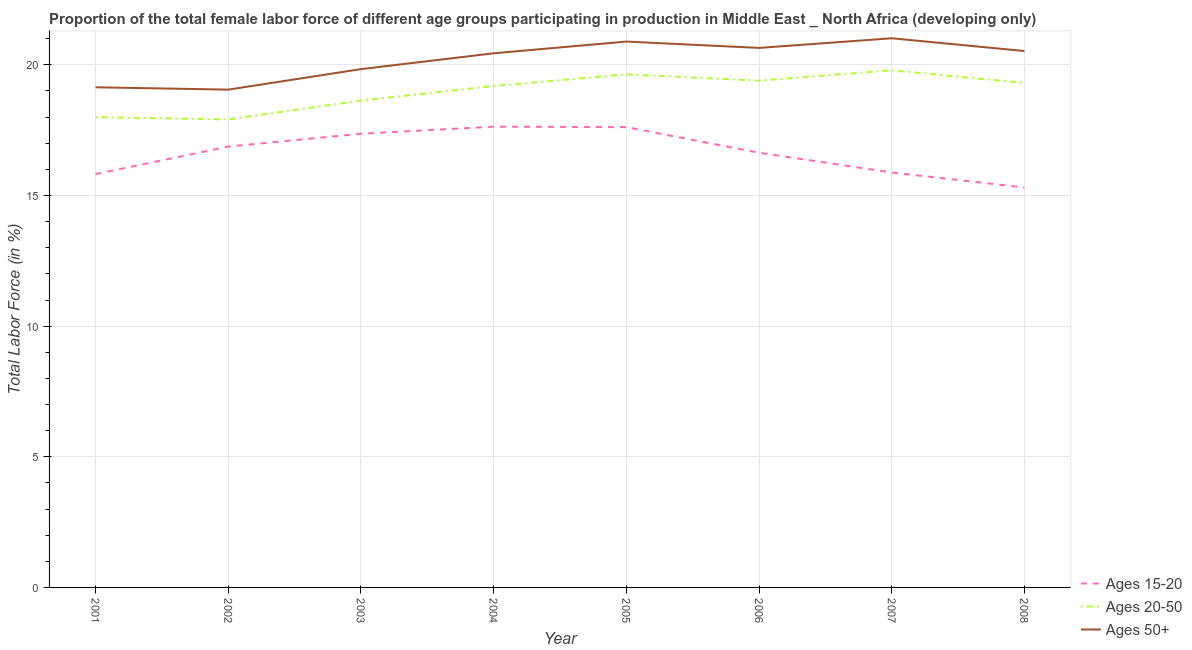What is the percentage of female labor force above age 50 in 2003?
Your response must be concise. 19.84. Across all years, what is the maximum percentage of female labor force within the age group 20-50?
Your response must be concise. 19.79. Across all years, what is the minimum percentage of female labor force within the age group 20-50?
Make the answer very short. 17.91. In which year was the percentage of female labor force within the age group 20-50 minimum?
Provide a short and direct response. 2002. What is the total percentage of female labor force above age 50 in the graph?
Ensure brevity in your answer.  161.56. What is the difference between the percentage of female labor force within the age group 20-50 in 2001 and that in 2005?
Your response must be concise. -1.64. What is the difference between the percentage of female labor force within the age group 20-50 in 2007 and the percentage of female labor force within the age group 15-20 in 2006?
Keep it short and to the point. 3.16. What is the average percentage of female labor force within the age group 20-50 per year?
Provide a succinct answer. 18.98. In the year 2008, what is the difference between the percentage of female labor force within the age group 15-20 and percentage of female labor force within the age group 20-50?
Ensure brevity in your answer.  -4. What is the ratio of the percentage of female labor force above age 50 in 2002 to that in 2003?
Provide a succinct answer. 0.96. Is the percentage of female labor force within the age group 15-20 in 2003 less than that in 2005?
Your response must be concise. Yes. Is the difference between the percentage of female labor force within the age group 20-50 in 2002 and 2003 greater than the difference between the percentage of female labor force above age 50 in 2002 and 2003?
Give a very brief answer. Yes. What is the difference between the highest and the second highest percentage of female labor force above age 50?
Provide a short and direct response. 0.13. What is the difference between the highest and the lowest percentage of female labor force above age 50?
Provide a short and direct response. 1.97. Does the percentage of female labor force above age 50 monotonically increase over the years?
Your response must be concise. No. Is the percentage of female labor force within the age group 20-50 strictly less than the percentage of female labor force within the age group 15-20 over the years?
Provide a succinct answer. No. How many years are there in the graph?
Your answer should be compact. 8. Are the values on the major ticks of Y-axis written in scientific E-notation?
Offer a very short reply. No. Does the graph contain any zero values?
Keep it short and to the point. No. Does the graph contain grids?
Offer a very short reply. Yes. Where does the legend appear in the graph?
Give a very brief answer. Bottom right. What is the title of the graph?
Your answer should be compact. Proportion of the total female labor force of different age groups participating in production in Middle East _ North Africa (developing only). What is the label or title of the X-axis?
Provide a succinct answer. Year. What is the label or title of the Y-axis?
Keep it short and to the point. Total Labor Force (in %). What is the Total Labor Force (in %) in Ages 15-20 in 2001?
Make the answer very short. 15.82. What is the Total Labor Force (in %) of Ages 20-50 in 2001?
Your answer should be compact. 18. What is the Total Labor Force (in %) of Ages 50+ in 2001?
Your answer should be compact. 19.14. What is the Total Labor Force (in %) in Ages 15-20 in 2002?
Make the answer very short. 16.87. What is the Total Labor Force (in %) in Ages 20-50 in 2002?
Give a very brief answer. 17.91. What is the Total Labor Force (in %) of Ages 50+ in 2002?
Provide a succinct answer. 19.05. What is the Total Labor Force (in %) of Ages 15-20 in 2003?
Your answer should be very brief. 17.37. What is the Total Labor Force (in %) in Ages 20-50 in 2003?
Provide a succinct answer. 18.63. What is the Total Labor Force (in %) of Ages 50+ in 2003?
Give a very brief answer. 19.84. What is the Total Labor Force (in %) of Ages 15-20 in 2004?
Your response must be concise. 17.63. What is the Total Labor Force (in %) in Ages 20-50 in 2004?
Provide a succinct answer. 19.19. What is the Total Labor Force (in %) in Ages 50+ in 2004?
Provide a succinct answer. 20.44. What is the Total Labor Force (in %) in Ages 15-20 in 2005?
Ensure brevity in your answer.  17.62. What is the Total Labor Force (in %) in Ages 20-50 in 2005?
Keep it short and to the point. 19.64. What is the Total Labor Force (in %) of Ages 50+ in 2005?
Offer a very short reply. 20.89. What is the Total Labor Force (in %) in Ages 15-20 in 2006?
Offer a very short reply. 16.64. What is the Total Labor Force (in %) of Ages 20-50 in 2006?
Offer a very short reply. 19.4. What is the Total Labor Force (in %) in Ages 50+ in 2006?
Give a very brief answer. 20.65. What is the Total Labor Force (in %) in Ages 15-20 in 2007?
Provide a succinct answer. 15.88. What is the Total Labor Force (in %) of Ages 20-50 in 2007?
Make the answer very short. 19.79. What is the Total Labor Force (in %) in Ages 50+ in 2007?
Your response must be concise. 21.02. What is the Total Labor Force (in %) in Ages 15-20 in 2008?
Your answer should be compact. 15.31. What is the Total Labor Force (in %) of Ages 20-50 in 2008?
Provide a succinct answer. 19.31. What is the Total Labor Force (in %) in Ages 50+ in 2008?
Keep it short and to the point. 20.53. Across all years, what is the maximum Total Labor Force (in %) in Ages 15-20?
Provide a short and direct response. 17.63. Across all years, what is the maximum Total Labor Force (in %) in Ages 20-50?
Your answer should be very brief. 19.79. Across all years, what is the maximum Total Labor Force (in %) of Ages 50+?
Make the answer very short. 21.02. Across all years, what is the minimum Total Labor Force (in %) of Ages 15-20?
Provide a short and direct response. 15.31. Across all years, what is the minimum Total Labor Force (in %) of Ages 20-50?
Your response must be concise. 17.91. Across all years, what is the minimum Total Labor Force (in %) of Ages 50+?
Give a very brief answer. 19.05. What is the total Total Labor Force (in %) of Ages 15-20 in the graph?
Keep it short and to the point. 133.13. What is the total Total Labor Force (in %) of Ages 20-50 in the graph?
Provide a short and direct response. 151.87. What is the total Total Labor Force (in %) in Ages 50+ in the graph?
Your response must be concise. 161.56. What is the difference between the Total Labor Force (in %) of Ages 15-20 in 2001 and that in 2002?
Your answer should be compact. -1.05. What is the difference between the Total Labor Force (in %) in Ages 20-50 in 2001 and that in 2002?
Keep it short and to the point. 0.09. What is the difference between the Total Labor Force (in %) of Ages 50+ in 2001 and that in 2002?
Give a very brief answer. 0.09. What is the difference between the Total Labor Force (in %) in Ages 15-20 in 2001 and that in 2003?
Offer a very short reply. -1.55. What is the difference between the Total Labor Force (in %) in Ages 20-50 in 2001 and that in 2003?
Ensure brevity in your answer.  -0.63. What is the difference between the Total Labor Force (in %) in Ages 50+ in 2001 and that in 2003?
Make the answer very short. -0.69. What is the difference between the Total Labor Force (in %) of Ages 15-20 in 2001 and that in 2004?
Ensure brevity in your answer.  -1.82. What is the difference between the Total Labor Force (in %) in Ages 20-50 in 2001 and that in 2004?
Offer a very short reply. -1.19. What is the difference between the Total Labor Force (in %) of Ages 50+ in 2001 and that in 2004?
Your response must be concise. -1.3. What is the difference between the Total Labor Force (in %) of Ages 15-20 in 2001 and that in 2005?
Offer a terse response. -1.8. What is the difference between the Total Labor Force (in %) of Ages 20-50 in 2001 and that in 2005?
Offer a very short reply. -1.64. What is the difference between the Total Labor Force (in %) of Ages 50+ in 2001 and that in 2005?
Your response must be concise. -1.75. What is the difference between the Total Labor Force (in %) in Ages 15-20 in 2001 and that in 2006?
Ensure brevity in your answer.  -0.82. What is the difference between the Total Labor Force (in %) of Ages 20-50 in 2001 and that in 2006?
Give a very brief answer. -1.4. What is the difference between the Total Labor Force (in %) of Ages 50+ in 2001 and that in 2006?
Keep it short and to the point. -1.51. What is the difference between the Total Labor Force (in %) of Ages 15-20 in 2001 and that in 2007?
Give a very brief answer. -0.06. What is the difference between the Total Labor Force (in %) in Ages 20-50 in 2001 and that in 2007?
Keep it short and to the point. -1.79. What is the difference between the Total Labor Force (in %) in Ages 50+ in 2001 and that in 2007?
Ensure brevity in your answer.  -1.88. What is the difference between the Total Labor Force (in %) in Ages 15-20 in 2001 and that in 2008?
Offer a very short reply. 0.51. What is the difference between the Total Labor Force (in %) in Ages 20-50 in 2001 and that in 2008?
Your response must be concise. -1.31. What is the difference between the Total Labor Force (in %) of Ages 50+ in 2001 and that in 2008?
Make the answer very short. -1.39. What is the difference between the Total Labor Force (in %) of Ages 15-20 in 2002 and that in 2003?
Your answer should be compact. -0.49. What is the difference between the Total Labor Force (in %) of Ages 20-50 in 2002 and that in 2003?
Make the answer very short. -0.72. What is the difference between the Total Labor Force (in %) in Ages 50+ in 2002 and that in 2003?
Ensure brevity in your answer.  -0.78. What is the difference between the Total Labor Force (in %) of Ages 15-20 in 2002 and that in 2004?
Provide a short and direct response. -0.76. What is the difference between the Total Labor Force (in %) in Ages 20-50 in 2002 and that in 2004?
Your answer should be very brief. -1.28. What is the difference between the Total Labor Force (in %) in Ages 50+ in 2002 and that in 2004?
Your answer should be compact. -1.39. What is the difference between the Total Labor Force (in %) of Ages 15-20 in 2002 and that in 2005?
Offer a very short reply. -0.74. What is the difference between the Total Labor Force (in %) in Ages 20-50 in 2002 and that in 2005?
Provide a short and direct response. -1.72. What is the difference between the Total Labor Force (in %) in Ages 50+ in 2002 and that in 2005?
Give a very brief answer. -1.84. What is the difference between the Total Labor Force (in %) of Ages 15-20 in 2002 and that in 2006?
Provide a succinct answer. 0.24. What is the difference between the Total Labor Force (in %) of Ages 20-50 in 2002 and that in 2006?
Ensure brevity in your answer.  -1.48. What is the difference between the Total Labor Force (in %) of Ages 50+ in 2002 and that in 2006?
Give a very brief answer. -1.6. What is the difference between the Total Labor Force (in %) in Ages 20-50 in 2002 and that in 2007?
Ensure brevity in your answer.  -1.88. What is the difference between the Total Labor Force (in %) of Ages 50+ in 2002 and that in 2007?
Your answer should be compact. -1.97. What is the difference between the Total Labor Force (in %) of Ages 15-20 in 2002 and that in 2008?
Ensure brevity in your answer.  1.56. What is the difference between the Total Labor Force (in %) of Ages 20-50 in 2002 and that in 2008?
Make the answer very short. -1.4. What is the difference between the Total Labor Force (in %) of Ages 50+ in 2002 and that in 2008?
Offer a very short reply. -1.48. What is the difference between the Total Labor Force (in %) in Ages 15-20 in 2003 and that in 2004?
Your response must be concise. -0.27. What is the difference between the Total Labor Force (in %) of Ages 20-50 in 2003 and that in 2004?
Your answer should be compact. -0.56. What is the difference between the Total Labor Force (in %) in Ages 50+ in 2003 and that in 2004?
Provide a succinct answer. -0.61. What is the difference between the Total Labor Force (in %) in Ages 15-20 in 2003 and that in 2005?
Offer a terse response. -0.25. What is the difference between the Total Labor Force (in %) of Ages 20-50 in 2003 and that in 2005?
Offer a very short reply. -1. What is the difference between the Total Labor Force (in %) of Ages 50+ in 2003 and that in 2005?
Offer a terse response. -1.05. What is the difference between the Total Labor Force (in %) in Ages 15-20 in 2003 and that in 2006?
Provide a short and direct response. 0.73. What is the difference between the Total Labor Force (in %) of Ages 20-50 in 2003 and that in 2006?
Give a very brief answer. -0.76. What is the difference between the Total Labor Force (in %) of Ages 50+ in 2003 and that in 2006?
Ensure brevity in your answer.  -0.81. What is the difference between the Total Labor Force (in %) in Ages 15-20 in 2003 and that in 2007?
Ensure brevity in your answer.  1.48. What is the difference between the Total Labor Force (in %) of Ages 20-50 in 2003 and that in 2007?
Give a very brief answer. -1.16. What is the difference between the Total Labor Force (in %) of Ages 50+ in 2003 and that in 2007?
Provide a succinct answer. -1.18. What is the difference between the Total Labor Force (in %) in Ages 15-20 in 2003 and that in 2008?
Your answer should be very brief. 2.06. What is the difference between the Total Labor Force (in %) in Ages 20-50 in 2003 and that in 2008?
Your answer should be very brief. -0.67. What is the difference between the Total Labor Force (in %) of Ages 50+ in 2003 and that in 2008?
Offer a terse response. -0.69. What is the difference between the Total Labor Force (in %) in Ages 15-20 in 2004 and that in 2005?
Your answer should be very brief. 0.02. What is the difference between the Total Labor Force (in %) of Ages 20-50 in 2004 and that in 2005?
Give a very brief answer. -0.44. What is the difference between the Total Labor Force (in %) of Ages 50+ in 2004 and that in 2005?
Your response must be concise. -0.45. What is the difference between the Total Labor Force (in %) in Ages 15-20 in 2004 and that in 2006?
Your answer should be compact. 1. What is the difference between the Total Labor Force (in %) of Ages 20-50 in 2004 and that in 2006?
Your answer should be very brief. -0.21. What is the difference between the Total Labor Force (in %) in Ages 50+ in 2004 and that in 2006?
Your answer should be compact. -0.21. What is the difference between the Total Labor Force (in %) of Ages 15-20 in 2004 and that in 2007?
Your answer should be compact. 1.75. What is the difference between the Total Labor Force (in %) in Ages 20-50 in 2004 and that in 2007?
Offer a terse response. -0.6. What is the difference between the Total Labor Force (in %) of Ages 50+ in 2004 and that in 2007?
Your answer should be compact. -0.57. What is the difference between the Total Labor Force (in %) in Ages 15-20 in 2004 and that in 2008?
Provide a short and direct response. 2.33. What is the difference between the Total Labor Force (in %) of Ages 20-50 in 2004 and that in 2008?
Ensure brevity in your answer.  -0.12. What is the difference between the Total Labor Force (in %) of Ages 50+ in 2004 and that in 2008?
Your answer should be compact. -0.09. What is the difference between the Total Labor Force (in %) in Ages 20-50 in 2005 and that in 2006?
Your answer should be compact. 0.24. What is the difference between the Total Labor Force (in %) in Ages 50+ in 2005 and that in 2006?
Offer a very short reply. 0.24. What is the difference between the Total Labor Force (in %) in Ages 15-20 in 2005 and that in 2007?
Your response must be concise. 1.74. What is the difference between the Total Labor Force (in %) in Ages 20-50 in 2005 and that in 2007?
Offer a terse response. -0.16. What is the difference between the Total Labor Force (in %) of Ages 50+ in 2005 and that in 2007?
Your answer should be compact. -0.13. What is the difference between the Total Labor Force (in %) in Ages 15-20 in 2005 and that in 2008?
Your response must be concise. 2.31. What is the difference between the Total Labor Force (in %) of Ages 20-50 in 2005 and that in 2008?
Your answer should be very brief. 0.33. What is the difference between the Total Labor Force (in %) of Ages 50+ in 2005 and that in 2008?
Offer a very short reply. 0.36. What is the difference between the Total Labor Force (in %) in Ages 15-20 in 2006 and that in 2007?
Ensure brevity in your answer.  0.76. What is the difference between the Total Labor Force (in %) of Ages 20-50 in 2006 and that in 2007?
Your answer should be very brief. -0.4. What is the difference between the Total Labor Force (in %) in Ages 50+ in 2006 and that in 2007?
Give a very brief answer. -0.37. What is the difference between the Total Labor Force (in %) of Ages 15-20 in 2006 and that in 2008?
Offer a very short reply. 1.33. What is the difference between the Total Labor Force (in %) of Ages 20-50 in 2006 and that in 2008?
Offer a very short reply. 0.09. What is the difference between the Total Labor Force (in %) in Ages 50+ in 2006 and that in 2008?
Provide a short and direct response. 0.12. What is the difference between the Total Labor Force (in %) of Ages 15-20 in 2007 and that in 2008?
Your response must be concise. 0.57. What is the difference between the Total Labor Force (in %) of Ages 20-50 in 2007 and that in 2008?
Give a very brief answer. 0.49. What is the difference between the Total Labor Force (in %) of Ages 50+ in 2007 and that in 2008?
Make the answer very short. 0.49. What is the difference between the Total Labor Force (in %) of Ages 15-20 in 2001 and the Total Labor Force (in %) of Ages 20-50 in 2002?
Provide a short and direct response. -2.09. What is the difference between the Total Labor Force (in %) in Ages 15-20 in 2001 and the Total Labor Force (in %) in Ages 50+ in 2002?
Offer a very short reply. -3.23. What is the difference between the Total Labor Force (in %) in Ages 20-50 in 2001 and the Total Labor Force (in %) in Ages 50+ in 2002?
Offer a terse response. -1.05. What is the difference between the Total Labor Force (in %) in Ages 15-20 in 2001 and the Total Labor Force (in %) in Ages 20-50 in 2003?
Provide a succinct answer. -2.81. What is the difference between the Total Labor Force (in %) in Ages 15-20 in 2001 and the Total Labor Force (in %) in Ages 50+ in 2003?
Make the answer very short. -4.02. What is the difference between the Total Labor Force (in %) of Ages 20-50 in 2001 and the Total Labor Force (in %) of Ages 50+ in 2003?
Provide a succinct answer. -1.84. What is the difference between the Total Labor Force (in %) in Ages 15-20 in 2001 and the Total Labor Force (in %) in Ages 20-50 in 2004?
Offer a terse response. -3.37. What is the difference between the Total Labor Force (in %) in Ages 15-20 in 2001 and the Total Labor Force (in %) in Ages 50+ in 2004?
Provide a short and direct response. -4.62. What is the difference between the Total Labor Force (in %) in Ages 20-50 in 2001 and the Total Labor Force (in %) in Ages 50+ in 2004?
Offer a terse response. -2.44. What is the difference between the Total Labor Force (in %) of Ages 15-20 in 2001 and the Total Labor Force (in %) of Ages 20-50 in 2005?
Your response must be concise. -3.82. What is the difference between the Total Labor Force (in %) of Ages 15-20 in 2001 and the Total Labor Force (in %) of Ages 50+ in 2005?
Give a very brief answer. -5.07. What is the difference between the Total Labor Force (in %) of Ages 20-50 in 2001 and the Total Labor Force (in %) of Ages 50+ in 2005?
Give a very brief answer. -2.89. What is the difference between the Total Labor Force (in %) in Ages 15-20 in 2001 and the Total Labor Force (in %) in Ages 20-50 in 2006?
Provide a succinct answer. -3.58. What is the difference between the Total Labor Force (in %) in Ages 15-20 in 2001 and the Total Labor Force (in %) in Ages 50+ in 2006?
Your answer should be compact. -4.83. What is the difference between the Total Labor Force (in %) in Ages 20-50 in 2001 and the Total Labor Force (in %) in Ages 50+ in 2006?
Provide a succinct answer. -2.65. What is the difference between the Total Labor Force (in %) of Ages 15-20 in 2001 and the Total Labor Force (in %) of Ages 20-50 in 2007?
Provide a succinct answer. -3.97. What is the difference between the Total Labor Force (in %) of Ages 15-20 in 2001 and the Total Labor Force (in %) of Ages 50+ in 2007?
Offer a terse response. -5.2. What is the difference between the Total Labor Force (in %) in Ages 20-50 in 2001 and the Total Labor Force (in %) in Ages 50+ in 2007?
Offer a terse response. -3.02. What is the difference between the Total Labor Force (in %) of Ages 15-20 in 2001 and the Total Labor Force (in %) of Ages 20-50 in 2008?
Ensure brevity in your answer.  -3.49. What is the difference between the Total Labor Force (in %) in Ages 15-20 in 2001 and the Total Labor Force (in %) in Ages 50+ in 2008?
Provide a short and direct response. -4.71. What is the difference between the Total Labor Force (in %) of Ages 20-50 in 2001 and the Total Labor Force (in %) of Ages 50+ in 2008?
Your response must be concise. -2.53. What is the difference between the Total Labor Force (in %) in Ages 15-20 in 2002 and the Total Labor Force (in %) in Ages 20-50 in 2003?
Provide a short and direct response. -1.76. What is the difference between the Total Labor Force (in %) of Ages 15-20 in 2002 and the Total Labor Force (in %) of Ages 50+ in 2003?
Provide a succinct answer. -2.96. What is the difference between the Total Labor Force (in %) of Ages 20-50 in 2002 and the Total Labor Force (in %) of Ages 50+ in 2003?
Make the answer very short. -1.93. What is the difference between the Total Labor Force (in %) in Ages 15-20 in 2002 and the Total Labor Force (in %) in Ages 20-50 in 2004?
Make the answer very short. -2.32. What is the difference between the Total Labor Force (in %) in Ages 15-20 in 2002 and the Total Labor Force (in %) in Ages 50+ in 2004?
Provide a short and direct response. -3.57. What is the difference between the Total Labor Force (in %) in Ages 20-50 in 2002 and the Total Labor Force (in %) in Ages 50+ in 2004?
Offer a very short reply. -2.53. What is the difference between the Total Labor Force (in %) in Ages 15-20 in 2002 and the Total Labor Force (in %) in Ages 20-50 in 2005?
Your answer should be compact. -2.76. What is the difference between the Total Labor Force (in %) of Ages 15-20 in 2002 and the Total Labor Force (in %) of Ages 50+ in 2005?
Offer a terse response. -4.02. What is the difference between the Total Labor Force (in %) of Ages 20-50 in 2002 and the Total Labor Force (in %) of Ages 50+ in 2005?
Your response must be concise. -2.98. What is the difference between the Total Labor Force (in %) of Ages 15-20 in 2002 and the Total Labor Force (in %) of Ages 20-50 in 2006?
Your answer should be compact. -2.52. What is the difference between the Total Labor Force (in %) in Ages 15-20 in 2002 and the Total Labor Force (in %) in Ages 50+ in 2006?
Keep it short and to the point. -3.78. What is the difference between the Total Labor Force (in %) in Ages 20-50 in 2002 and the Total Labor Force (in %) in Ages 50+ in 2006?
Make the answer very short. -2.74. What is the difference between the Total Labor Force (in %) in Ages 15-20 in 2002 and the Total Labor Force (in %) in Ages 20-50 in 2007?
Your answer should be very brief. -2.92. What is the difference between the Total Labor Force (in %) of Ages 15-20 in 2002 and the Total Labor Force (in %) of Ages 50+ in 2007?
Provide a short and direct response. -4.15. What is the difference between the Total Labor Force (in %) of Ages 20-50 in 2002 and the Total Labor Force (in %) of Ages 50+ in 2007?
Provide a succinct answer. -3.11. What is the difference between the Total Labor Force (in %) in Ages 15-20 in 2002 and the Total Labor Force (in %) in Ages 20-50 in 2008?
Make the answer very short. -2.44. What is the difference between the Total Labor Force (in %) of Ages 15-20 in 2002 and the Total Labor Force (in %) of Ages 50+ in 2008?
Your answer should be very brief. -3.66. What is the difference between the Total Labor Force (in %) of Ages 20-50 in 2002 and the Total Labor Force (in %) of Ages 50+ in 2008?
Ensure brevity in your answer.  -2.62. What is the difference between the Total Labor Force (in %) of Ages 15-20 in 2003 and the Total Labor Force (in %) of Ages 20-50 in 2004?
Your answer should be compact. -1.83. What is the difference between the Total Labor Force (in %) in Ages 15-20 in 2003 and the Total Labor Force (in %) in Ages 50+ in 2004?
Keep it short and to the point. -3.08. What is the difference between the Total Labor Force (in %) in Ages 20-50 in 2003 and the Total Labor Force (in %) in Ages 50+ in 2004?
Your answer should be very brief. -1.81. What is the difference between the Total Labor Force (in %) in Ages 15-20 in 2003 and the Total Labor Force (in %) in Ages 20-50 in 2005?
Make the answer very short. -2.27. What is the difference between the Total Labor Force (in %) in Ages 15-20 in 2003 and the Total Labor Force (in %) in Ages 50+ in 2005?
Provide a short and direct response. -3.53. What is the difference between the Total Labor Force (in %) in Ages 20-50 in 2003 and the Total Labor Force (in %) in Ages 50+ in 2005?
Provide a short and direct response. -2.26. What is the difference between the Total Labor Force (in %) of Ages 15-20 in 2003 and the Total Labor Force (in %) of Ages 20-50 in 2006?
Your answer should be very brief. -2.03. What is the difference between the Total Labor Force (in %) of Ages 15-20 in 2003 and the Total Labor Force (in %) of Ages 50+ in 2006?
Offer a very short reply. -3.28. What is the difference between the Total Labor Force (in %) in Ages 20-50 in 2003 and the Total Labor Force (in %) in Ages 50+ in 2006?
Keep it short and to the point. -2.02. What is the difference between the Total Labor Force (in %) in Ages 15-20 in 2003 and the Total Labor Force (in %) in Ages 20-50 in 2007?
Your answer should be very brief. -2.43. What is the difference between the Total Labor Force (in %) of Ages 15-20 in 2003 and the Total Labor Force (in %) of Ages 50+ in 2007?
Provide a succinct answer. -3.65. What is the difference between the Total Labor Force (in %) in Ages 20-50 in 2003 and the Total Labor Force (in %) in Ages 50+ in 2007?
Make the answer very short. -2.38. What is the difference between the Total Labor Force (in %) in Ages 15-20 in 2003 and the Total Labor Force (in %) in Ages 20-50 in 2008?
Offer a very short reply. -1.94. What is the difference between the Total Labor Force (in %) in Ages 15-20 in 2003 and the Total Labor Force (in %) in Ages 50+ in 2008?
Provide a succinct answer. -3.16. What is the difference between the Total Labor Force (in %) in Ages 20-50 in 2003 and the Total Labor Force (in %) in Ages 50+ in 2008?
Give a very brief answer. -1.9. What is the difference between the Total Labor Force (in %) in Ages 15-20 in 2004 and the Total Labor Force (in %) in Ages 20-50 in 2005?
Make the answer very short. -2. What is the difference between the Total Labor Force (in %) of Ages 15-20 in 2004 and the Total Labor Force (in %) of Ages 50+ in 2005?
Offer a terse response. -3.26. What is the difference between the Total Labor Force (in %) in Ages 20-50 in 2004 and the Total Labor Force (in %) in Ages 50+ in 2005?
Ensure brevity in your answer.  -1.7. What is the difference between the Total Labor Force (in %) of Ages 15-20 in 2004 and the Total Labor Force (in %) of Ages 20-50 in 2006?
Ensure brevity in your answer.  -1.76. What is the difference between the Total Labor Force (in %) in Ages 15-20 in 2004 and the Total Labor Force (in %) in Ages 50+ in 2006?
Give a very brief answer. -3.01. What is the difference between the Total Labor Force (in %) of Ages 20-50 in 2004 and the Total Labor Force (in %) of Ages 50+ in 2006?
Keep it short and to the point. -1.46. What is the difference between the Total Labor Force (in %) of Ages 15-20 in 2004 and the Total Labor Force (in %) of Ages 20-50 in 2007?
Offer a very short reply. -2.16. What is the difference between the Total Labor Force (in %) in Ages 15-20 in 2004 and the Total Labor Force (in %) in Ages 50+ in 2007?
Your response must be concise. -3.38. What is the difference between the Total Labor Force (in %) of Ages 20-50 in 2004 and the Total Labor Force (in %) of Ages 50+ in 2007?
Your answer should be compact. -1.83. What is the difference between the Total Labor Force (in %) of Ages 15-20 in 2004 and the Total Labor Force (in %) of Ages 20-50 in 2008?
Ensure brevity in your answer.  -1.67. What is the difference between the Total Labor Force (in %) in Ages 15-20 in 2004 and the Total Labor Force (in %) in Ages 50+ in 2008?
Your answer should be very brief. -2.89. What is the difference between the Total Labor Force (in %) of Ages 20-50 in 2004 and the Total Labor Force (in %) of Ages 50+ in 2008?
Offer a very short reply. -1.34. What is the difference between the Total Labor Force (in %) of Ages 15-20 in 2005 and the Total Labor Force (in %) of Ages 20-50 in 2006?
Give a very brief answer. -1.78. What is the difference between the Total Labor Force (in %) in Ages 15-20 in 2005 and the Total Labor Force (in %) in Ages 50+ in 2006?
Provide a short and direct response. -3.03. What is the difference between the Total Labor Force (in %) of Ages 20-50 in 2005 and the Total Labor Force (in %) of Ages 50+ in 2006?
Offer a very short reply. -1.01. What is the difference between the Total Labor Force (in %) in Ages 15-20 in 2005 and the Total Labor Force (in %) in Ages 20-50 in 2007?
Your answer should be very brief. -2.18. What is the difference between the Total Labor Force (in %) of Ages 15-20 in 2005 and the Total Labor Force (in %) of Ages 50+ in 2007?
Keep it short and to the point. -3.4. What is the difference between the Total Labor Force (in %) of Ages 20-50 in 2005 and the Total Labor Force (in %) of Ages 50+ in 2007?
Your answer should be very brief. -1.38. What is the difference between the Total Labor Force (in %) of Ages 15-20 in 2005 and the Total Labor Force (in %) of Ages 20-50 in 2008?
Keep it short and to the point. -1.69. What is the difference between the Total Labor Force (in %) in Ages 15-20 in 2005 and the Total Labor Force (in %) in Ages 50+ in 2008?
Provide a succinct answer. -2.91. What is the difference between the Total Labor Force (in %) of Ages 20-50 in 2005 and the Total Labor Force (in %) of Ages 50+ in 2008?
Offer a terse response. -0.89. What is the difference between the Total Labor Force (in %) in Ages 15-20 in 2006 and the Total Labor Force (in %) in Ages 20-50 in 2007?
Your answer should be compact. -3.16. What is the difference between the Total Labor Force (in %) in Ages 15-20 in 2006 and the Total Labor Force (in %) in Ages 50+ in 2007?
Give a very brief answer. -4.38. What is the difference between the Total Labor Force (in %) in Ages 20-50 in 2006 and the Total Labor Force (in %) in Ages 50+ in 2007?
Keep it short and to the point. -1.62. What is the difference between the Total Labor Force (in %) in Ages 15-20 in 2006 and the Total Labor Force (in %) in Ages 20-50 in 2008?
Ensure brevity in your answer.  -2.67. What is the difference between the Total Labor Force (in %) in Ages 15-20 in 2006 and the Total Labor Force (in %) in Ages 50+ in 2008?
Ensure brevity in your answer.  -3.89. What is the difference between the Total Labor Force (in %) of Ages 20-50 in 2006 and the Total Labor Force (in %) of Ages 50+ in 2008?
Provide a short and direct response. -1.13. What is the difference between the Total Labor Force (in %) in Ages 15-20 in 2007 and the Total Labor Force (in %) in Ages 20-50 in 2008?
Offer a very short reply. -3.43. What is the difference between the Total Labor Force (in %) in Ages 15-20 in 2007 and the Total Labor Force (in %) in Ages 50+ in 2008?
Give a very brief answer. -4.65. What is the difference between the Total Labor Force (in %) of Ages 20-50 in 2007 and the Total Labor Force (in %) of Ages 50+ in 2008?
Your response must be concise. -0.74. What is the average Total Labor Force (in %) of Ages 15-20 per year?
Your answer should be very brief. 16.64. What is the average Total Labor Force (in %) of Ages 20-50 per year?
Your answer should be compact. 18.98. What is the average Total Labor Force (in %) in Ages 50+ per year?
Provide a short and direct response. 20.2. In the year 2001, what is the difference between the Total Labor Force (in %) in Ages 15-20 and Total Labor Force (in %) in Ages 20-50?
Provide a short and direct response. -2.18. In the year 2001, what is the difference between the Total Labor Force (in %) of Ages 15-20 and Total Labor Force (in %) of Ages 50+?
Your answer should be compact. -3.32. In the year 2001, what is the difference between the Total Labor Force (in %) in Ages 20-50 and Total Labor Force (in %) in Ages 50+?
Keep it short and to the point. -1.14. In the year 2002, what is the difference between the Total Labor Force (in %) in Ages 15-20 and Total Labor Force (in %) in Ages 20-50?
Your response must be concise. -1.04. In the year 2002, what is the difference between the Total Labor Force (in %) of Ages 15-20 and Total Labor Force (in %) of Ages 50+?
Your answer should be very brief. -2.18. In the year 2002, what is the difference between the Total Labor Force (in %) of Ages 20-50 and Total Labor Force (in %) of Ages 50+?
Offer a very short reply. -1.14. In the year 2003, what is the difference between the Total Labor Force (in %) in Ages 15-20 and Total Labor Force (in %) in Ages 20-50?
Your response must be concise. -1.27. In the year 2003, what is the difference between the Total Labor Force (in %) of Ages 15-20 and Total Labor Force (in %) of Ages 50+?
Your response must be concise. -2.47. In the year 2003, what is the difference between the Total Labor Force (in %) in Ages 20-50 and Total Labor Force (in %) in Ages 50+?
Keep it short and to the point. -1.2. In the year 2004, what is the difference between the Total Labor Force (in %) of Ages 15-20 and Total Labor Force (in %) of Ages 20-50?
Offer a very short reply. -1.56. In the year 2004, what is the difference between the Total Labor Force (in %) of Ages 15-20 and Total Labor Force (in %) of Ages 50+?
Keep it short and to the point. -2.81. In the year 2004, what is the difference between the Total Labor Force (in %) in Ages 20-50 and Total Labor Force (in %) in Ages 50+?
Make the answer very short. -1.25. In the year 2005, what is the difference between the Total Labor Force (in %) in Ages 15-20 and Total Labor Force (in %) in Ages 20-50?
Ensure brevity in your answer.  -2.02. In the year 2005, what is the difference between the Total Labor Force (in %) of Ages 15-20 and Total Labor Force (in %) of Ages 50+?
Provide a succinct answer. -3.27. In the year 2005, what is the difference between the Total Labor Force (in %) in Ages 20-50 and Total Labor Force (in %) in Ages 50+?
Keep it short and to the point. -1.26. In the year 2006, what is the difference between the Total Labor Force (in %) in Ages 15-20 and Total Labor Force (in %) in Ages 20-50?
Your response must be concise. -2.76. In the year 2006, what is the difference between the Total Labor Force (in %) of Ages 15-20 and Total Labor Force (in %) of Ages 50+?
Ensure brevity in your answer.  -4.01. In the year 2006, what is the difference between the Total Labor Force (in %) of Ages 20-50 and Total Labor Force (in %) of Ages 50+?
Ensure brevity in your answer.  -1.25. In the year 2007, what is the difference between the Total Labor Force (in %) in Ages 15-20 and Total Labor Force (in %) in Ages 20-50?
Make the answer very short. -3.91. In the year 2007, what is the difference between the Total Labor Force (in %) in Ages 15-20 and Total Labor Force (in %) in Ages 50+?
Keep it short and to the point. -5.14. In the year 2007, what is the difference between the Total Labor Force (in %) in Ages 20-50 and Total Labor Force (in %) in Ages 50+?
Provide a short and direct response. -1.22. In the year 2008, what is the difference between the Total Labor Force (in %) in Ages 15-20 and Total Labor Force (in %) in Ages 20-50?
Give a very brief answer. -4. In the year 2008, what is the difference between the Total Labor Force (in %) of Ages 15-20 and Total Labor Force (in %) of Ages 50+?
Your answer should be very brief. -5.22. In the year 2008, what is the difference between the Total Labor Force (in %) of Ages 20-50 and Total Labor Force (in %) of Ages 50+?
Give a very brief answer. -1.22. What is the ratio of the Total Labor Force (in %) in Ages 15-20 in 2001 to that in 2002?
Keep it short and to the point. 0.94. What is the ratio of the Total Labor Force (in %) of Ages 20-50 in 2001 to that in 2002?
Offer a terse response. 1. What is the ratio of the Total Labor Force (in %) in Ages 15-20 in 2001 to that in 2003?
Offer a terse response. 0.91. What is the ratio of the Total Labor Force (in %) in Ages 20-50 in 2001 to that in 2003?
Ensure brevity in your answer.  0.97. What is the ratio of the Total Labor Force (in %) in Ages 50+ in 2001 to that in 2003?
Offer a terse response. 0.96. What is the ratio of the Total Labor Force (in %) in Ages 15-20 in 2001 to that in 2004?
Your response must be concise. 0.9. What is the ratio of the Total Labor Force (in %) in Ages 20-50 in 2001 to that in 2004?
Keep it short and to the point. 0.94. What is the ratio of the Total Labor Force (in %) in Ages 50+ in 2001 to that in 2004?
Give a very brief answer. 0.94. What is the ratio of the Total Labor Force (in %) in Ages 15-20 in 2001 to that in 2005?
Ensure brevity in your answer.  0.9. What is the ratio of the Total Labor Force (in %) of Ages 20-50 in 2001 to that in 2005?
Give a very brief answer. 0.92. What is the ratio of the Total Labor Force (in %) in Ages 50+ in 2001 to that in 2005?
Your response must be concise. 0.92. What is the ratio of the Total Labor Force (in %) in Ages 15-20 in 2001 to that in 2006?
Make the answer very short. 0.95. What is the ratio of the Total Labor Force (in %) of Ages 20-50 in 2001 to that in 2006?
Keep it short and to the point. 0.93. What is the ratio of the Total Labor Force (in %) of Ages 50+ in 2001 to that in 2006?
Ensure brevity in your answer.  0.93. What is the ratio of the Total Labor Force (in %) of Ages 20-50 in 2001 to that in 2007?
Your response must be concise. 0.91. What is the ratio of the Total Labor Force (in %) of Ages 50+ in 2001 to that in 2007?
Your response must be concise. 0.91. What is the ratio of the Total Labor Force (in %) in Ages 15-20 in 2001 to that in 2008?
Make the answer very short. 1.03. What is the ratio of the Total Labor Force (in %) in Ages 20-50 in 2001 to that in 2008?
Offer a very short reply. 0.93. What is the ratio of the Total Labor Force (in %) in Ages 50+ in 2001 to that in 2008?
Make the answer very short. 0.93. What is the ratio of the Total Labor Force (in %) of Ages 15-20 in 2002 to that in 2003?
Your response must be concise. 0.97. What is the ratio of the Total Labor Force (in %) of Ages 20-50 in 2002 to that in 2003?
Offer a very short reply. 0.96. What is the ratio of the Total Labor Force (in %) of Ages 50+ in 2002 to that in 2003?
Keep it short and to the point. 0.96. What is the ratio of the Total Labor Force (in %) in Ages 15-20 in 2002 to that in 2004?
Offer a very short reply. 0.96. What is the ratio of the Total Labor Force (in %) of Ages 50+ in 2002 to that in 2004?
Offer a terse response. 0.93. What is the ratio of the Total Labor Force (in %) in Ages 15-20 in 2002 to that in 2005?
Provide a succinct answer. 0.96. What is the ratio of the Total Labor Force (in %) of Ages 20-50 in 2002 to that in 2005?
Offer a very short reply. 0.91. What is the ratio of the Total Labor Force (in %) of Ages 50+ in 2002 to that in 2005?
Keep it short and to the point. 0.91. What is the ratio of the Total Labor Force (in %) in Ages 15-20 in 2002 to that in 2006?
Keep it short and to the point. 1.01. What is the ratio of the Total Labor Force (in %) in Ages 20-50 in 2002 to that in 2006?
Keep it short and to the point. 0.92. What is the ratio of the Total Labor Force (in %) of Ages 50+ in 2002 to that in 2006?
Your response must be concise. 0.92. What is the ratio of the Total Labor Force (in %) of Ages 15-20 in 2002 to that in 2007?
Provide a succinct answer. 1.06. What is the ratio of the Total Labor Force (in %) in Ages 20-50 in 2002 to that in 2007?
Your answer should be compact. 0.9. What is the ratio of the Total Labor Force (in %) in Ages 50+ in 2002 to that in 2007?
Provide a short and direct response. 0.91. What is the ratio of the Total Labor Force (in %) of Ages 15-20 in 2002 to that in 2008?
Make the answer very short. 1.1. What is the ratio of the Total Labor Force (in %) of Ages 20-50 in 2002 to that in 2008?
Provide a succinct answer. 0.93. What is the ratio of the Total Labor Force (in %) in Ages 50+ in 2002 to that in 2008?
Make the answer very short. 0.93. What is the ratio of the Total Labor Force (in %) of Ages 15-20 in 2003 to that in 2004?
Your answer should be very brief. 0.98. What is the ratio of the Total Labor Force (in %) of Ages 50+ in 2003 to that in 2004?
Your response must be concise. 0.97. What is the ratio of the Total Labor Force (in %) in Ages 15-20 in 2003 to that in 2005?
Make the answer very short. 0.99. What is the ratio of the Total Labor Force (in %) in Ages 20-50 in 2003 to that in 2005?
Offer a very short reply. 0.95. What is the ratio of the Total Labor Force (in %) of Ages 50+ in 2003 to that in 2005?
Your response must be concise. 0.95. What is the ratio of the Total Labor Force (in %) of Ages 15-20 in 2003 to that in 2006?
Give a very brief answer. 1.04. What is the ratio of the Total Labor Force (in %) in Ages 20-50 in 2003 to that in 2006?
Keep it short and to the point. 0.96. What is the ratio of the Total Labor Force (in %) of Ages 50+ in 2003 to that in 2006?
Your answer should be very brief. 0.96. What is the ratio of the Total Labor Force (in %) of Ages 15-20 in 2003 to that in 2007?
Provide a succinct answer. 1.09. What is the ratio of the Total Labor Force (in %) in Ages 20-50 in 2003 to that in 2007?
Make the answer very short. 0.94. What is the ratio of the Total Labor Force (in %) of Ages 50+ in 2003 to that in 2007?
Offer a very short reply. 0.94. What is the ratio of the Total Labor Force (in %) in Ages 15-20 in 2003 to that in 2008?
Keep it short and to the point. 1.13. What is the ratio of the Total Labor Force (in %) of Ages 20-50 in 2003 to that in 2008?
Your answer should be compact. 0.97. What is the ratio of the Total Labor Force (in %) of Ages 50+ in 2003 to that in 2008?
Provide a short and direct response. 0.97. What is the ratio of the Total Labor Force (in %) of Ages 15-20 in 2004 to that in 2005?
Your response must be concise. 1. What is the ratio of the Total Labor Force (in %) of Ages 20-50 in 2004 to that in 2005?
Ensure brevity in your answer.  0.98. What is the ratio of the Total Labor Force (in %) in Ages 50+ in 2004 to that in 2005?
Your response must be concise. 0.98. What is the ratio of the Total Labor Force (in %) of Ages 15-20 in 2004 to that in 2006?
Offer a terse response. 1.06. What is the ratio of the Total Labor Force (in %) in Ages 50+ in 2004 to that in 2006?
Give a very brief answer. 0.99. What is the ratio of the Total Labor Force (in %) in Ages 15-20 in 2004 to that in 2007?
Give a very brief answer. 1.11. What is the ratio of the Total Labor Force (in %) in Ages 20-50 in 2004 to that in 2007?
Your answer should be very brief. 0.97. What is the ratio of the Total Labor Force (in %) in Ages 50+ in 2004 to that in 2007?
Your answer should be compact. 0.97. What is the ratio of the Total Labor Force (in %) in Ages 15-20 in 2004 to that in 2008?
Offer a very short reply. 1.15. What is the ratio of the Total Labor Force (in %) in Ages 15-20 in 2005 to that in 2006?
Offer a very short reply. 1.06. What is the ratio of the Total Labor Force (in %) of Ages 20-50 in 2005 to that in 2006?
Offer a very short reply. 1.01. What is the ratio of the Total Labor Force (in %) of Ages 50+ in 2005 to that in 2006?
Your answer should be very brief. 1.01. What is the ratio of the Total Labor Force (in %) in Ages 15-20 in 2005 to that in 2007?
Provide a succinct answer. 1.11. What is the ratio of the Total Labor Force (in %) of Ages 20-50 in 2005 to that in 2007?
Give a very brief answer. 0.99. What is the ratio of the Total Labor Force (in %) in Ages 50+ in 2005 to that in 2007?
Keep it short and to the point. 0.99. What is the ratio of the Total Labor Force (in %) in Ages 15-20 in 2005 to that in 2008?
Provide a short and direct response. 1.15. What is the ratio of the Total Labor Force (in %) in Ages 50+ in 2005 to that in 2008?
Ensure brevity in your answer.  1.02. What is the ratio of the Total Labor Force (in %) in Ages 15-20 in 2006 to that in 2007?
Provide a succinct answer. 1.05. What is the ratio of the Total Labor Force (in %) of Ages 50+ in 2006 to that in 2007?
Your answer should be compact. 0.98. What is the ratio of the Total Labor Force (in %) of Ages 15-20 in 2006 to that in 2008?
Provide a short and direct response. 1.09. What is the ratio of the Total Labor Force (in %) of Ages 20-50 in 2006 to that in 2008?
Make the answer very short. 1. What is the ratio of the Total Labor Force (in %) of Ages 50+ in 2006 to that in 2008?
Give a very brief answer. 1.01. What is the ratio of the Total Labor Force (in %) in Ages 15-20 in 2007 to that in 2008?
Provide a succinct answer. 1.04. What is the ratio of the Total Labor Force (in %) in Ages 20-50 in 2007 to that in 2008?
Your answer should be compact. 1.03. What is the ratio of the Total Labor Force (in %) in Ages 50+ in 2007 to that in 2008?
Keep it short and to the point. 1.02. What is the difference between the highest and the second highest Total Labor Force (in %) in Ages 15-20?
Your response must be concise. 0.02. What is the difference between the highest and the second highest Total Labor Force (in %) of Ages 20-50?
Offer a terse response. 0.16. What is the difference between the highest and the second highest Total Labor Force (in %) in Ages 50+?
Offer a very short reply. 0.13. What is the difference between the highest and the lowest Total Labor Force (in %) in Ages 15-20?
Make the answer very short. 2.33. What is the difference between the highest and the lowest Total Labor Force (in %) in Ages 20-50?
Your answer should be compact. 1.88. What is the difference between the highest and the lowest Total Labor Force (in %) of Ages 50+?
Your answer should be very brief. 1.97. 